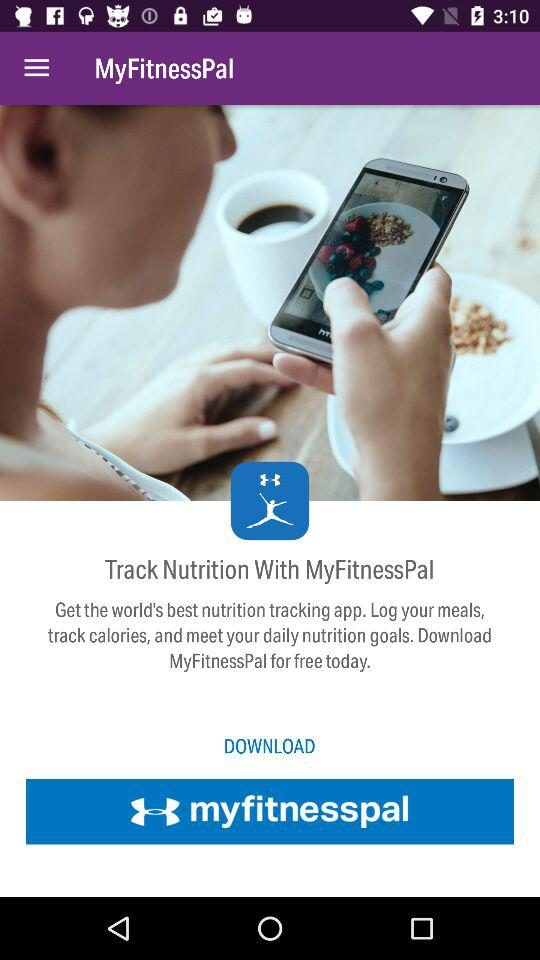What is the app name? The app name is "MyFitnessPal". 